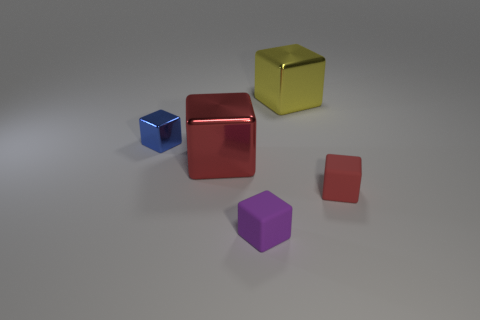Subtract all big yellow cubes. How many cubes are left? 4 Add 1 large shiny cubes. How many objects exist? 6 Subtract all blue cubes. Subtract all gray cylinders. How many cubes are left? 4 Subtract all green cylinders. How many purple blocks are left? 1 Subtract all tiny purple rubber objects. Subtract all green cylinders. How many objects are left? 4 Add 1 large yellow objects. How many large yellow objects are left? 2 Add 5 tiny purple cubes. How many tiny purple cubes exist? 6 Subtract all red cubes. How many cubes are left? 3 Subtract 1 blue blocks. How many objects are left? 4 Subtract 4 blocks. How many blocks are left? 1 